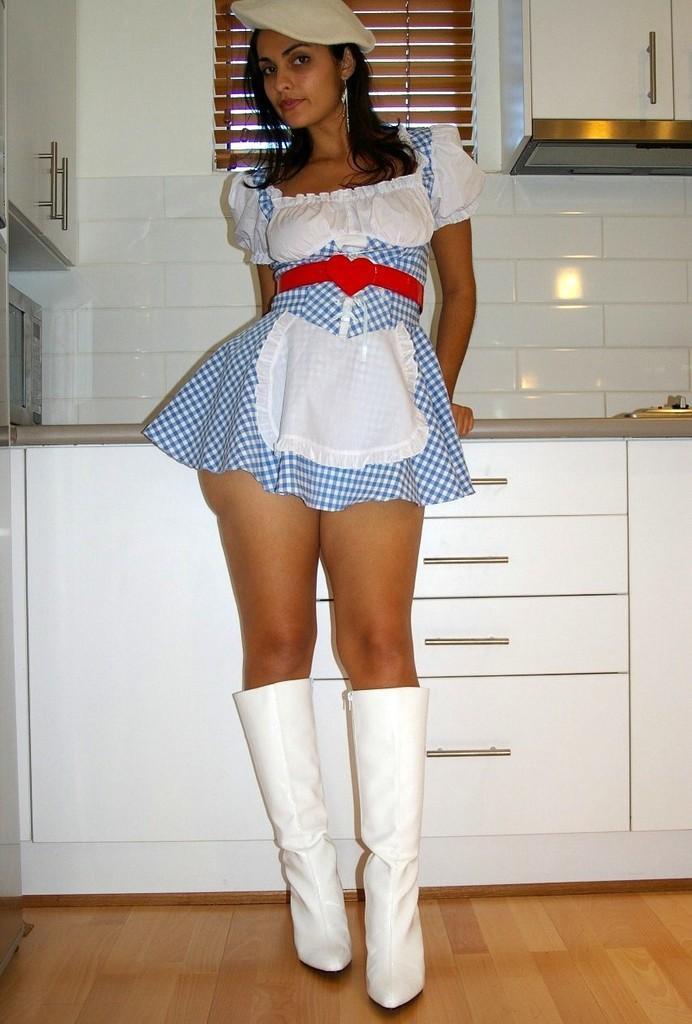Describe this image in one or two sentences. As we can see in the image there are white color tiles, cupboards and a woman standing over here. 